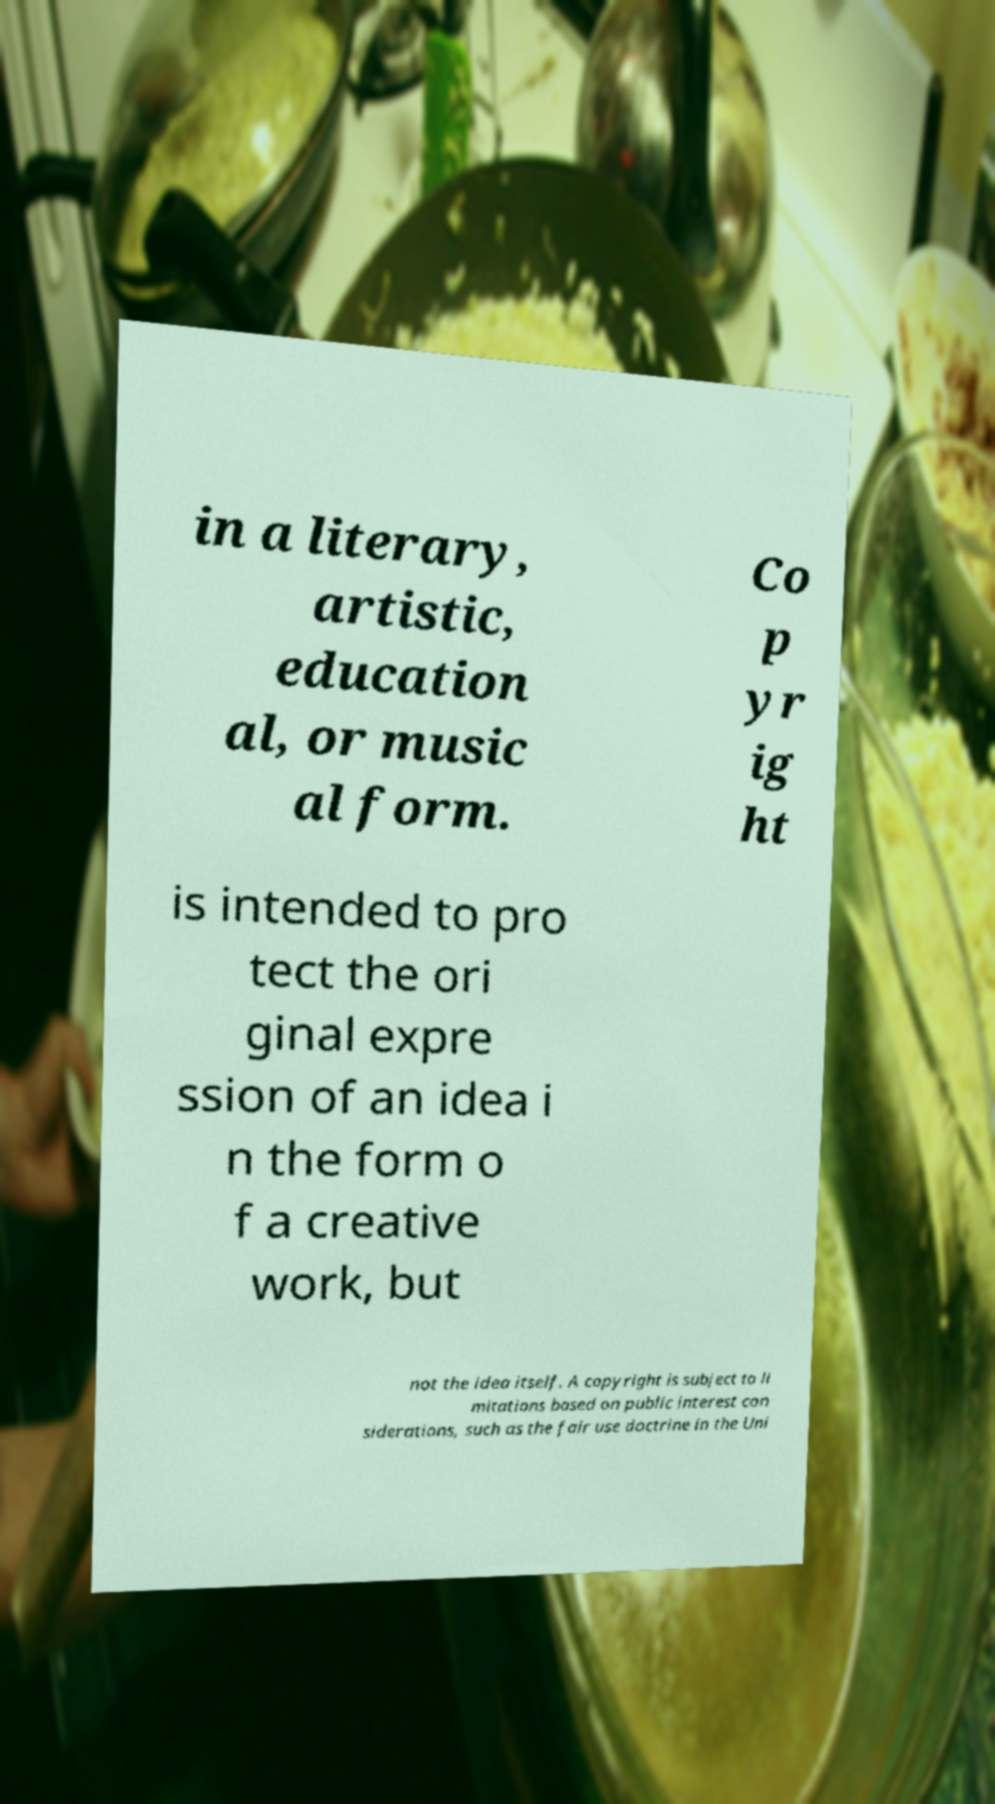Please read and relay the text visible in this image. What does it say? in a literary, artistic, education al, or music al form. Co p yr ig ht is intended to pro tect the ori ginal expre ssion of an idea i n the form o f a creative work, but not the idea itself. A copyright is subject to li mitations based on public interest con siderations, such as the fair use doctrine in the Uni 